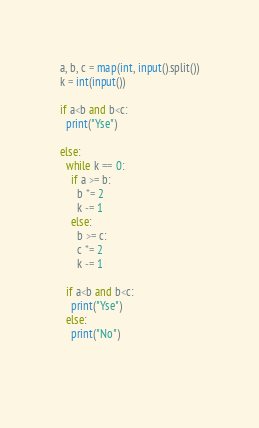<code> <loc_0><loc_0><loc_500><loc_500><_Python_>a, b, c = map(int, input().split())
k = int(input())

if a<b and b<c:
  print("Yse")

else:
  while k == 0:
    if a >= b:
      b *= 2
      k -= 1
    else:
      b >= c:
      c *= 2
      k -= 1
  
  if a<b and b<c:
    print("Yse")
  else:
    print("No")
    
    </code> 